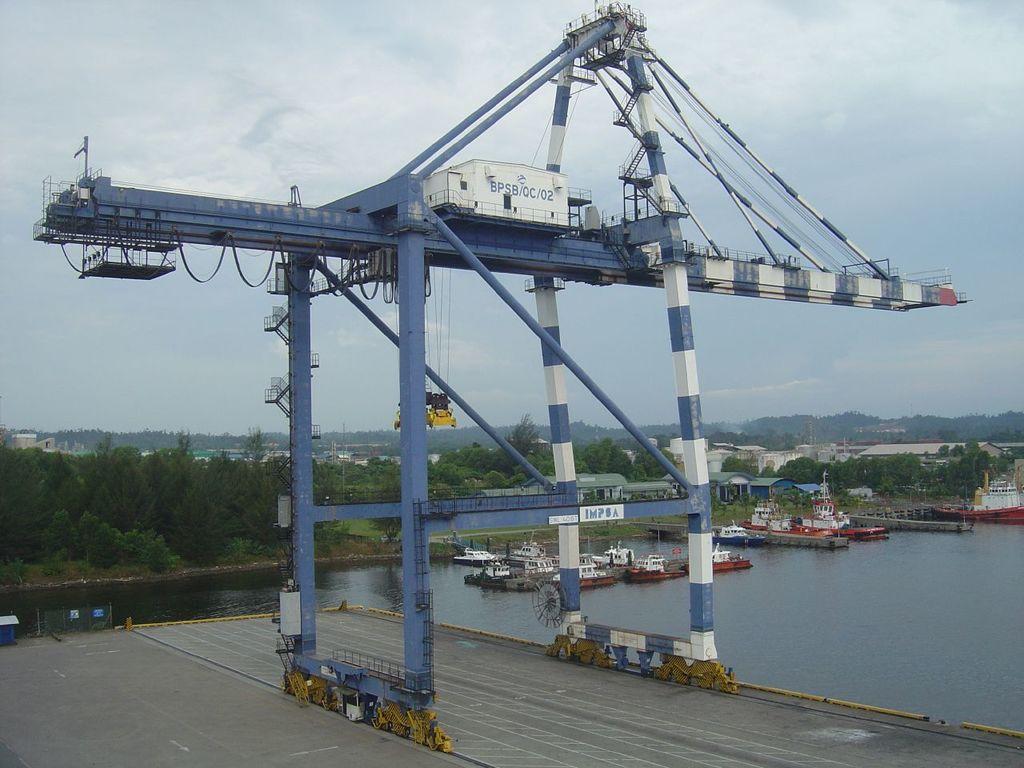Can you describe this image briefly? In this picture, we can see crane with some poles, wires, and some objects attached to it, we can see the road, water, boats, ground with trees, buildings and the sky with clouds. 